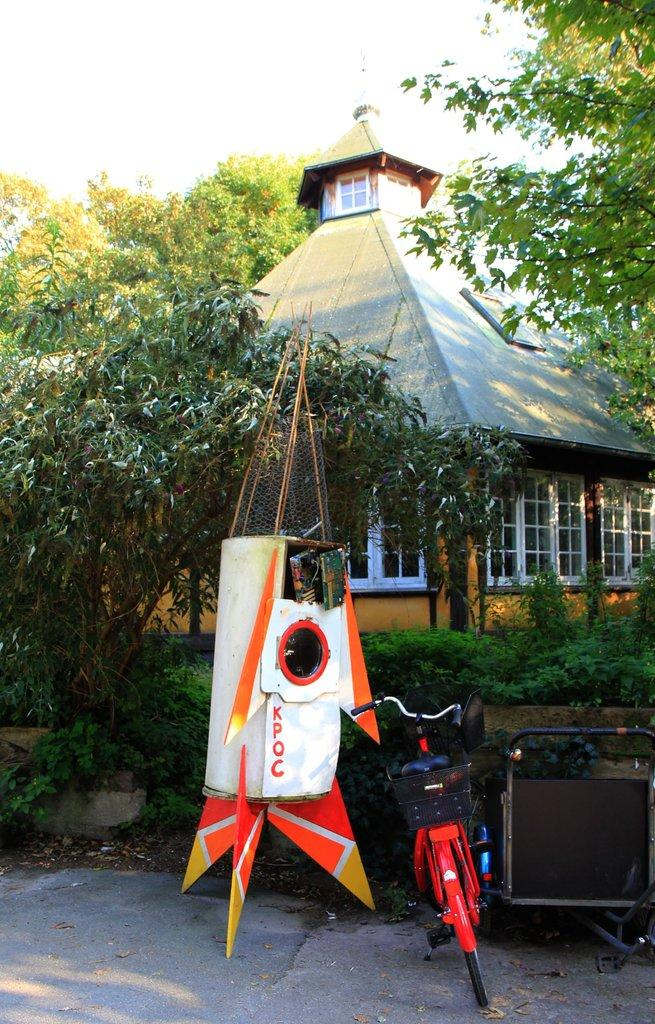What type of vehicle is in the image? There is a red bicycle in the image. What other object can be seen in the image? There is a white object in the image. What is written on the white object? Something is written on the white object. What can be seen in the background of the image? There are trees and a building in the background of the image. What toys are the committee members playing with in the image? There is no committee or toys present in the image. Who is the friend standing next to the bicycle in the image? There is no friend present in the image; only the red bicycle and the white object are visible. 